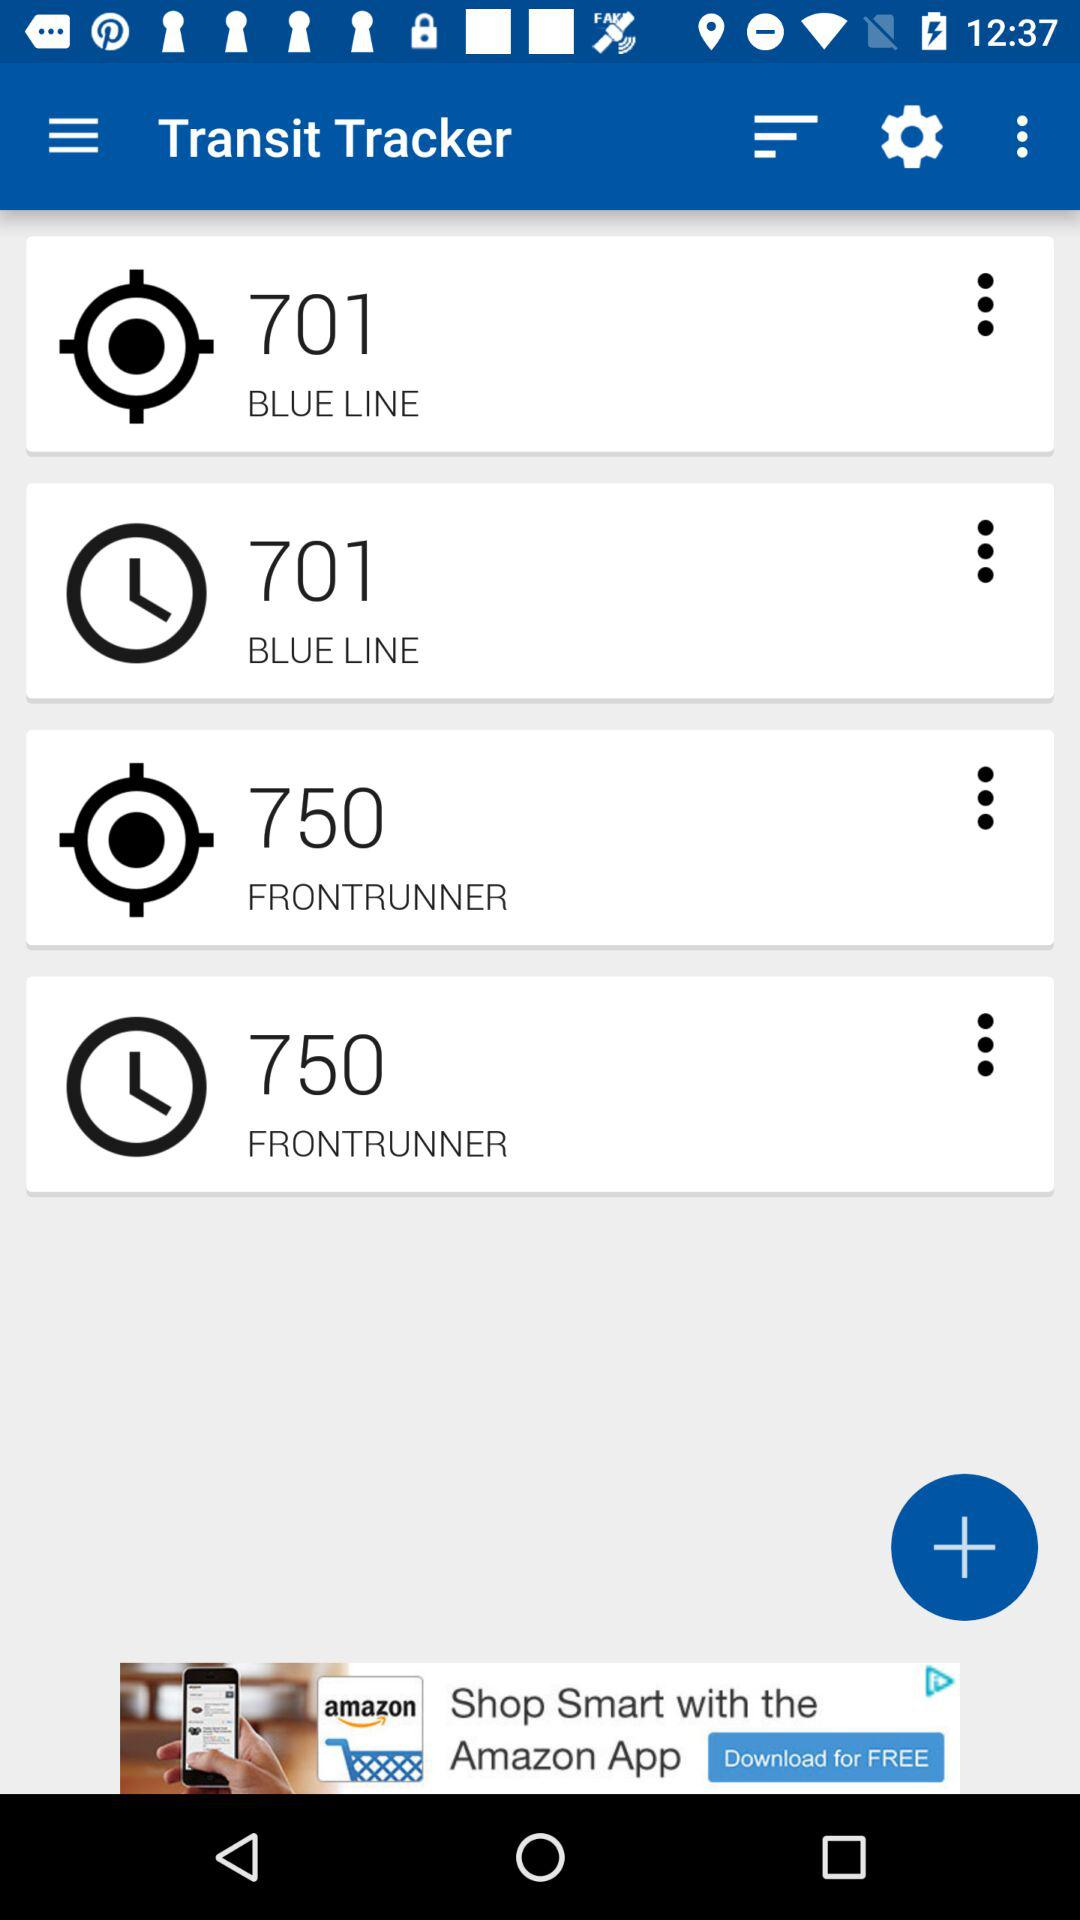What is the value of location blueline?
When the provided information is insufficient, respond with <no answer>. <no answer> 